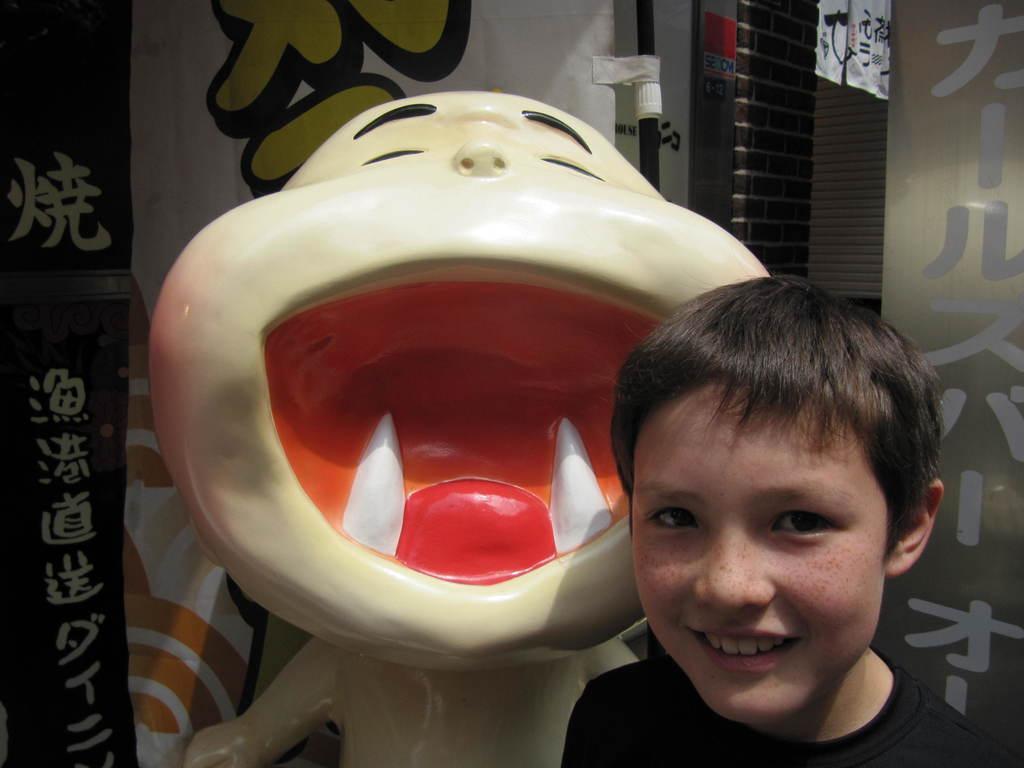Please provide a concise description of this image. In this picture we can see a boy and behind the boy there is a statue and a wall. 